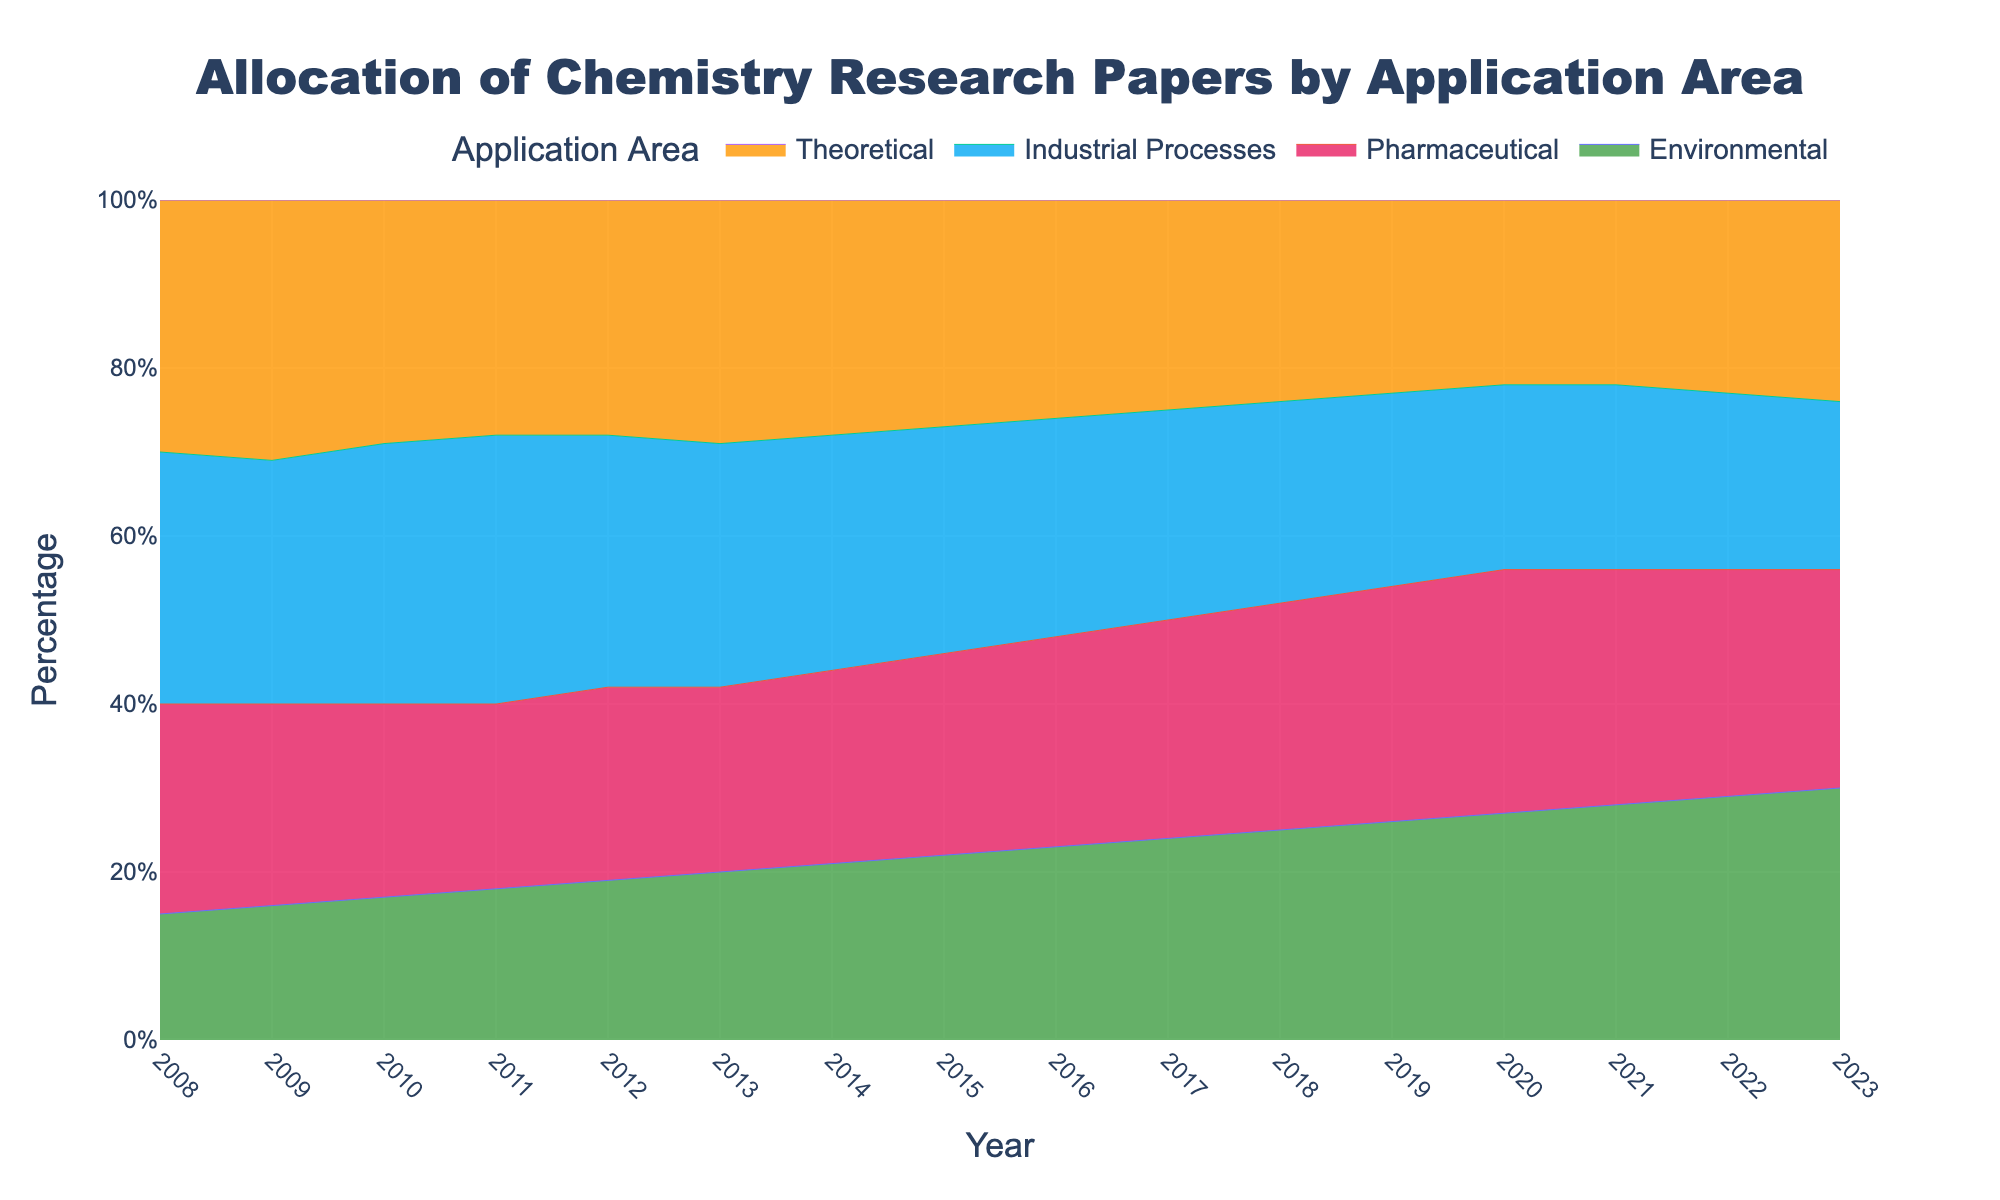What's the title of the figure? The title of the figure is located at the top center of the chart. It provides a summary of what the chart represents.
Answer: Allocation of Chemistry Research Papers by Application Area How many application areas are displayed in the chart? The chart shows different areas with distinct colors and names in the legend. Count these areas to get the total number.
Answer: 4 What color represents the Environmental application area? Each application area has a unique color. Look for the Environmental category in the legend and note its associated color.
Answer: Green In which year did Industrial Processes research papers occupy the highest percentage? Examine the 100% Stacked Area Chart and focus on the Industrial Processes area. The year at the highest point of its area indicates the peak percentage.
Answer: 2011 What is the trend in the percentage allocation of Theoretical papers from 2008 to 2023? Observe the area representing Theoretical papers from left to right (2008 to 2023). Look for increasing, decreasing, or steady patterns.
Answer: Decreasing Between 2008 and 2023, how many times did the percentage of Environmental papers increase year-over-year? Check the year-over-year changes in the Environmental area. Count the number of years when the percentage increased from the previous year.
Answer: 15 In which year did Pharmaceutical papers have the same percentage as the previous year? Identify the Pharmaceutical area and compare sequential years to spot when the percentage remained unchanged.
Answer: 2021 Which application area had the smallest percentage in 2023? Observe the Stacked Area Chart and compare the final values of each application area in 2023. The smallest one will be the answer.
Answer: Industrial Processes How did the combined percentage of Environmental and Pharmaceutical papers change from 2008 to 2023? Add the percentages of Environmental and Pharmaceutical for both 2008 and 2023. Compare the sums to determine the change.
Answer: Increased What is the percentage difference between Industrial Processes and Theoretical papers in 2013? Identify the percentages for both Industrial Processes and Theoretical papers in 2013 and subtract one from the other to find the difference.
Answer: 0 